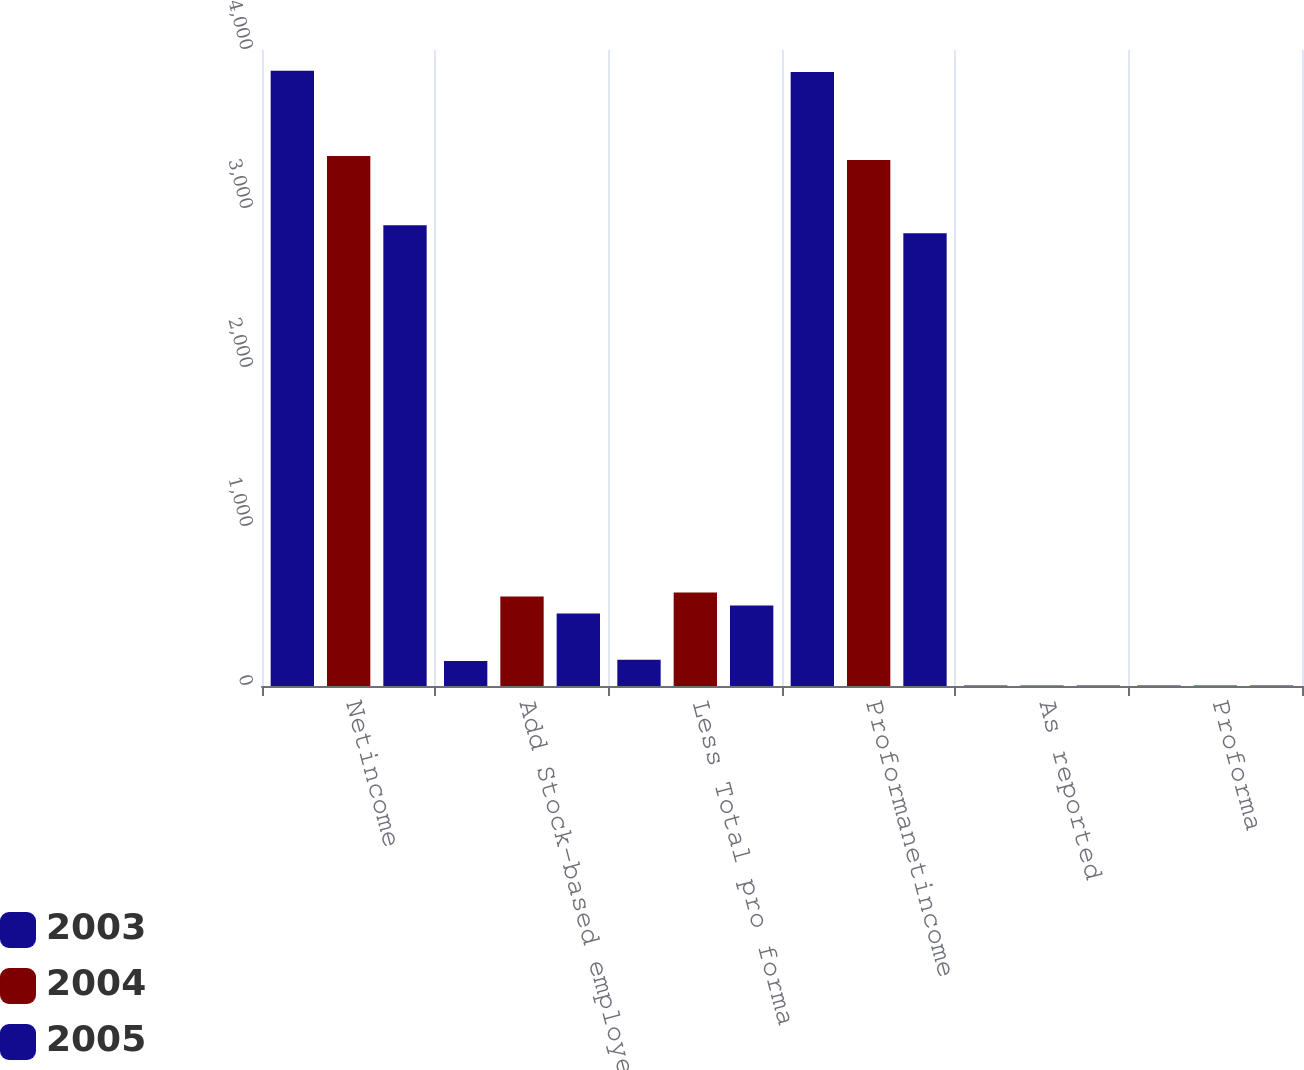Convert chart. <chart><loc_0><loc_0><loc_500><loc_500><stacked_bar_chart><ecel><fcel>Netincome<fcel>Add Stock-based employee<fcel>Less Total pro forma<fcel>Proformanetincome<fcel>As reported<fcel>Proforma<nl><fcel>2003<fcel>3870<fcel>157<fcel>165<fcel>3862<fcel>3.47<fcel>3.46<nl><fcel>2004<fcel>3333<fcel>563<fcel>588<fcel>3308<fcel>2.93<fcel>2.91<nl><fcel>2005<fcel>2898<fcel>456<fcel>507<fcel>2847<fcel>2.55<fcel>2.5<nl></chart> 